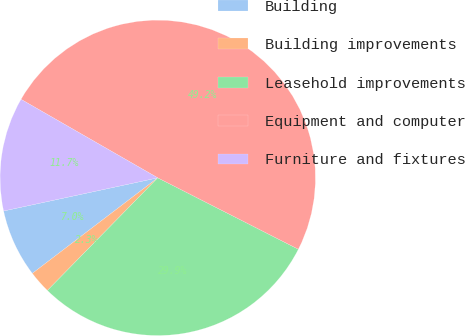Convert chart to OTSL. <chart><loc_0><loc_0><loc_500><loc_500><pie_chart><fcel>Building<fcel>Building improvements<fcel>Leasehold improvements<fcel>Equipment and computer<fcel>Furniture and fixtures<nl><fcel>6.99%<fcel>2.3%<fcel>29.86%<fcel>49.19%<fcel>11.67%<nl></chart> 